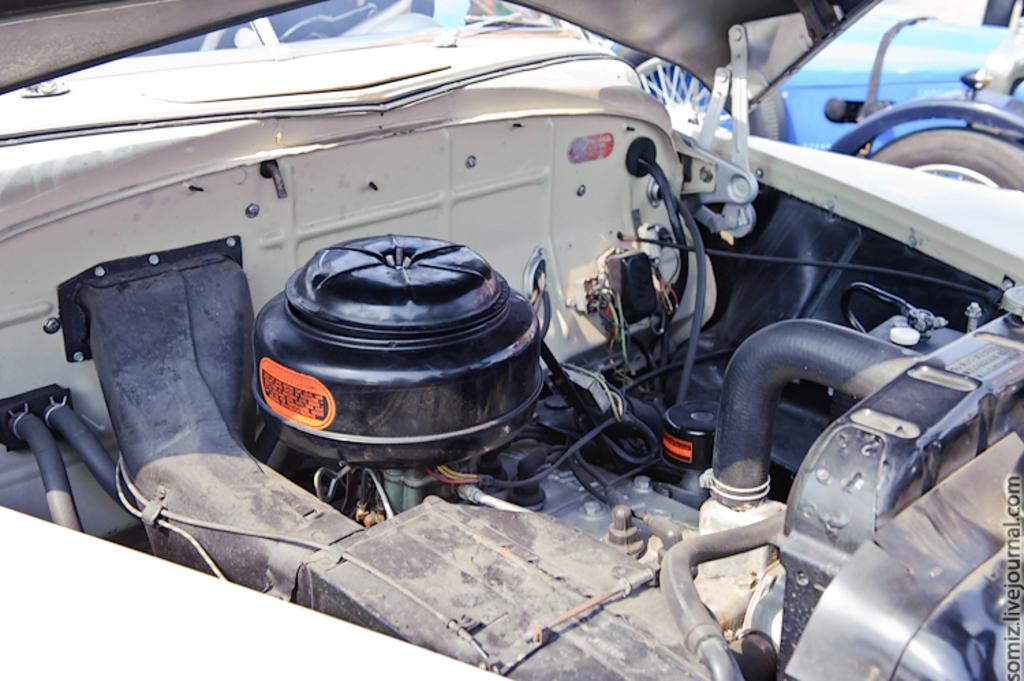What type of setting is depicted in the image? The image is an inside view of a vehicle. Can you describe anything visible outside the vehicle in the image? There is another vehicle visible in the background of the image. How many trees can be seen through the window in the image? There is no window visible in the image, and therefore no trees can be seen through it. 